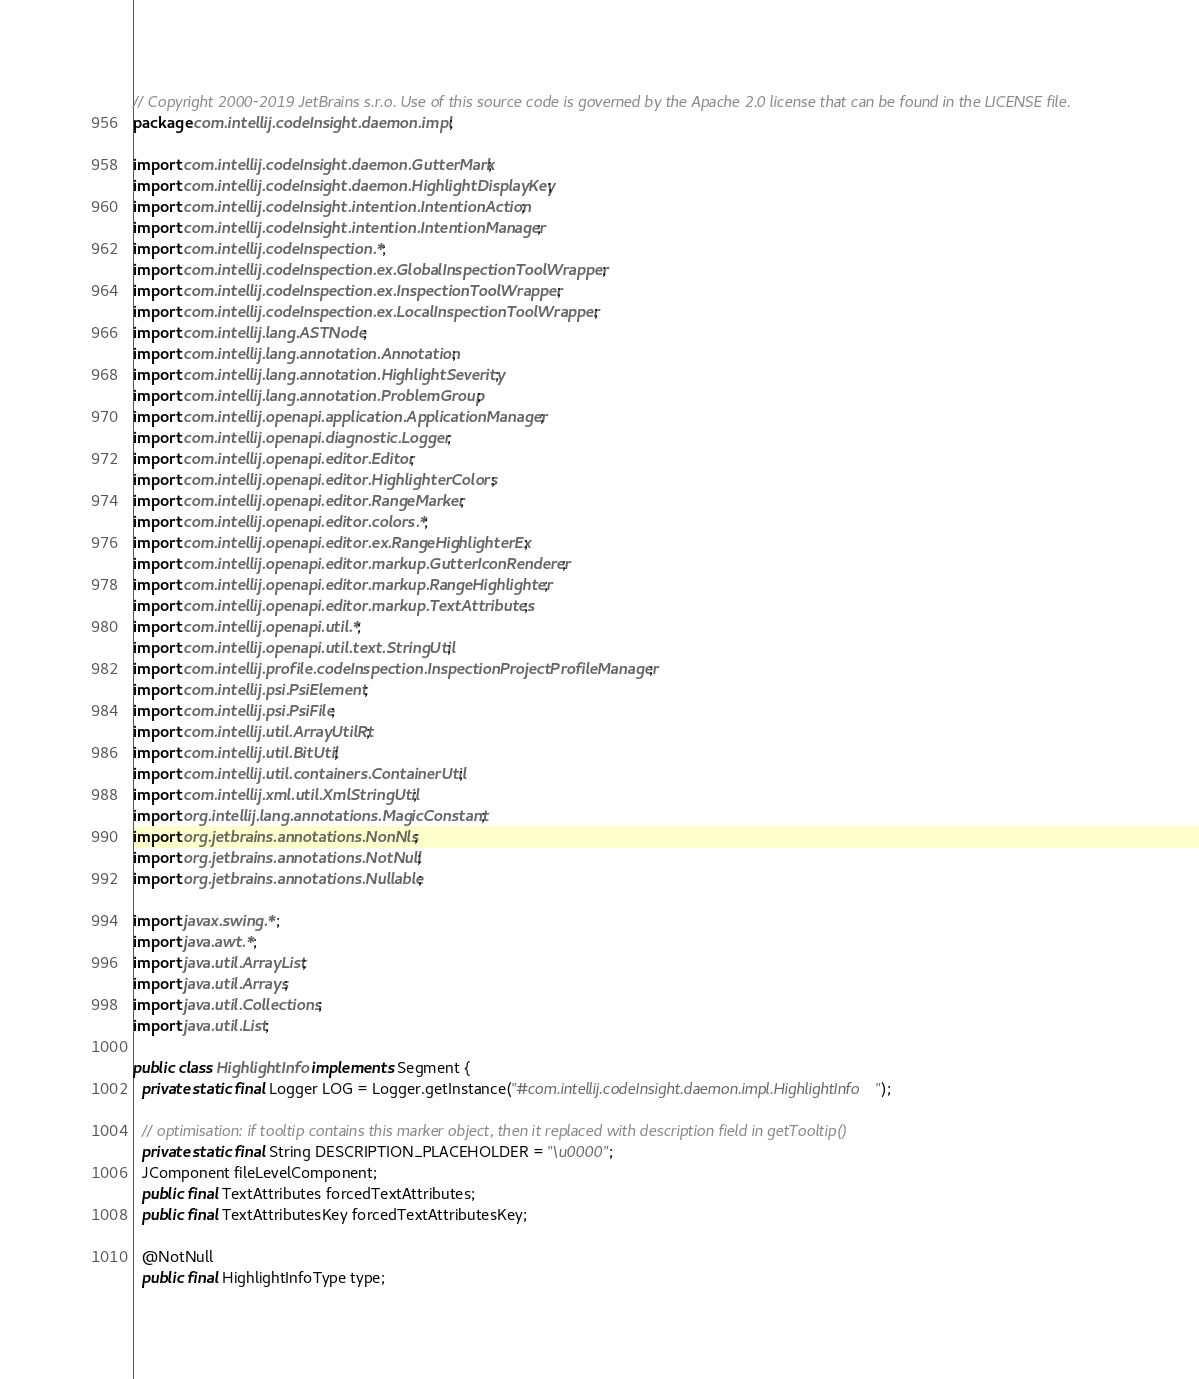<code> <loc_0><loc_0><loc_500><loc_500><_Java_>// Copyright 2000-2019 JetBrains s.r.o. Use of this source code is governed by the Apache 2.0 license that can be found in the LICENSE file.
package com.intellij.codeInsight.daemon.impl;

import com.intellij.codeInsight.daemon.GutterMark;
import com.intellij.codeInsight.daemon.HighlightDisplayKey;
import com.intellij.codeInsight.intention.IntentionAction;
import com.intellij.codeInsight.intention.IntentionManager;
import com.intellij.codeInspection.*;
import com.intellij.codeInspection.ex.GlobalInspectionToolWrapper;
import com.intellij.codeInspection.ex.InspectionToolWrapper;
import com.intellij.codeInspection.ex.LocalInspectionToolWrapper;
import com.intellij.lang.ASTNode;
import com.intellij.lang.annotation.Annotation;
import com.intellij.lang.annotation.HighlightSeverity;
import com.intellij.lang.annotation.ProblemGroup;
import com.intellij.openapi.application.ApplicationManager;
import com.intellij.openapi.diagnostic.Logger;
import com.intellij.openapi.editor.Editor;
import com.intellij.openapi.editor.HighlighterColors;
import com.intellij.openapi.editor.RangeMarker;
import com.intellij.openapi.editor.colors.*;
import com.intellij.openapi.editor.ex.RangeHighlighterEx;
import com.intellij.openapi.editor.markup.GutterIconRenderer;
import com.intellij.openapi.editor.markup.RangeHighlighter;
import com.intellij.openapi.editor.markup.TextAttributes;
import com.intellij.openapi.util.*;
import com.intellij.openapi.util.text.StringUtil;
import com.intellij.profile.codeInspection.InspectionProjectProfileManager;
import com.intellij.psi.PsiElement;
import com.intellij.psi.PsiFile;
import com.intellij.util.ArrayUtilRt;
import com.intellij.util.BitUtil;
import com.intellij.util.containers.ContainerUtil;
import com.intellij.xml.util.XmlStringUtil;
import org.intellij.lang.annotations.MagicConstant;
import org.jetbrains.annotations.NonNls;
import org.jetbrains.annotations.NotNull;
import org.jetbrains.annotations.Nullable;

import javax.swing.*;
import java.awt.*;
import java.util.ArrayList;
import java.util.Arrays;
import java.util.Collections;
import java.util.List;

public class HighlightInfo implements Segment {
  private static final Logger LOG = Logger.getInstance("#com.intellij.codeInsight.daemon.impl.HighlightInfo");

  // optimisation: if tooltip contains this marker object, then it replaced with description field in getTooltip()
  private static final String DESCRIPTION_PLACEHOLDER = "\u0000";
  JComponent fileLevelComponent;
  public final TextAttributes forcedTextAttributes;
  public final TextAttributesKey forcedTextAttributesKey;

  @NotNull
  public final HighlightInfoType type;</code> 